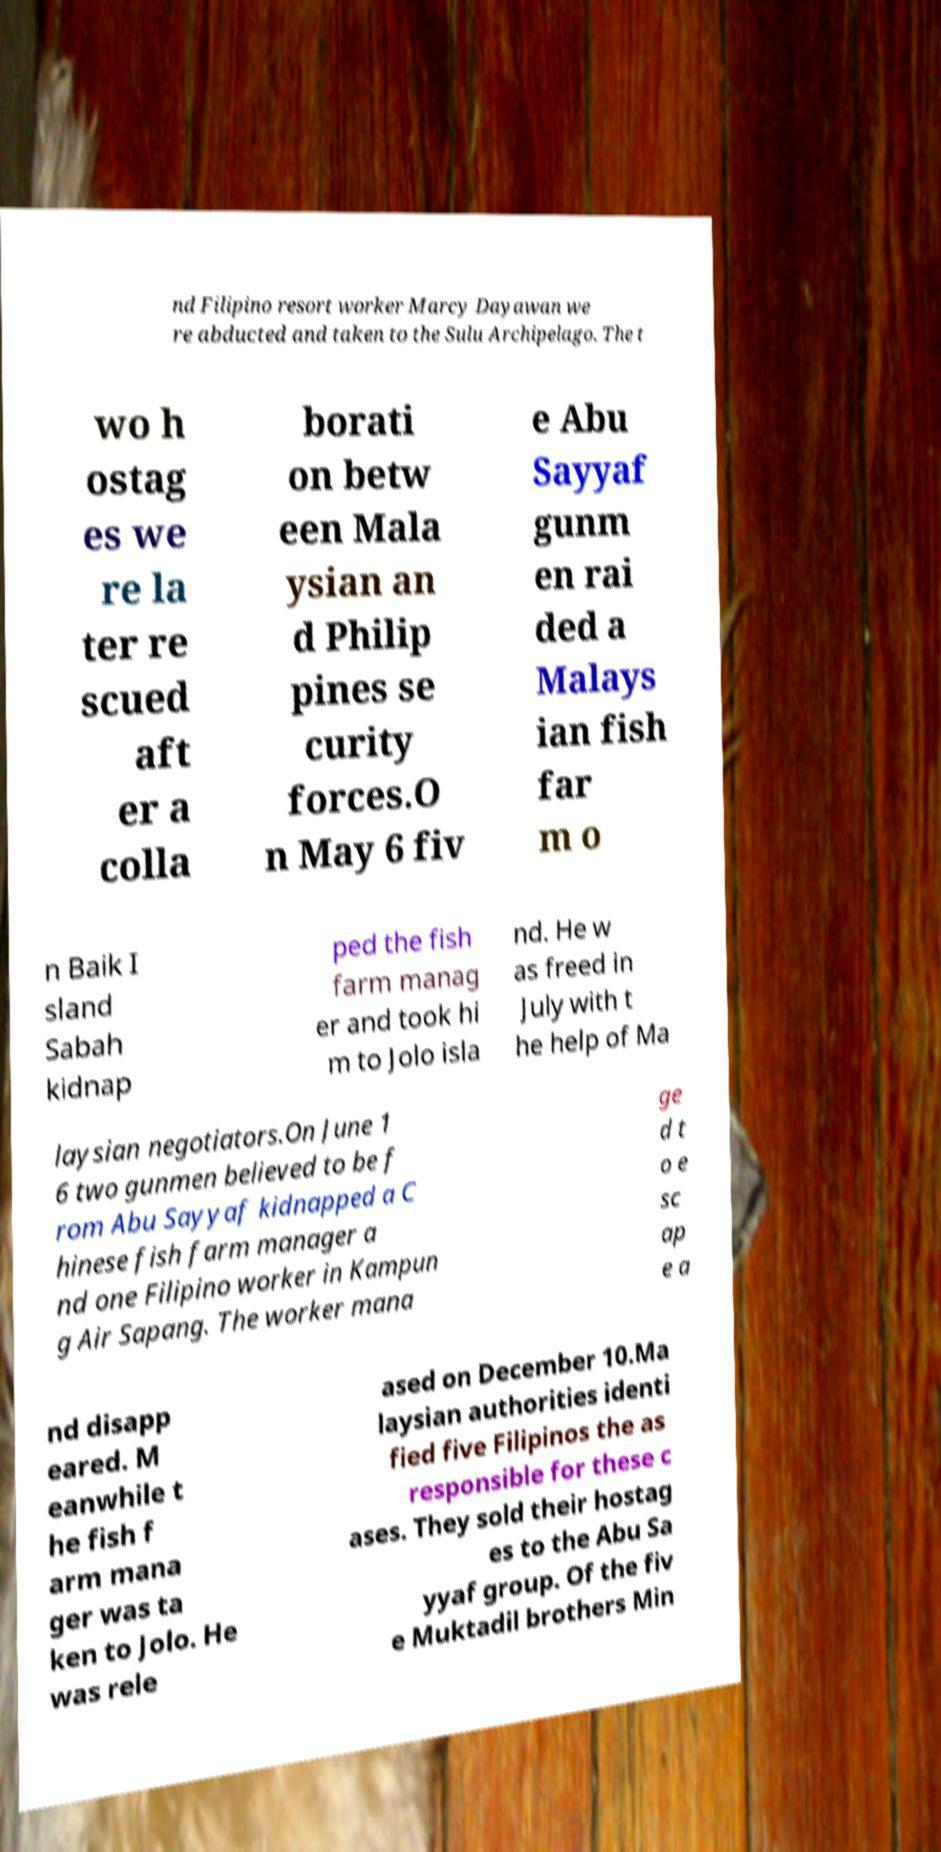For documentation purposes, I need the text within this image transcribed. Could you provide that? nd Filipino resort worker Marcy Dayawan we re abducted and taken to the Sulu Archipelago. The t wo h ostag es we re la ter re scued aft er a colla borati on betw een Mala ysian an d Philip pines se curity forces.O n May 6 fiv e Abu Sayyaf gunm en rai ded a Malays ian fish far m o n Baik I sland Sabah kidnap ped the fish farm manag er and took hi m to Jolo isla nd. He w as freed in July with t he help of Ma laysian negotiators.On June 1 6 two gunmen believed to be f rom Abu Sayyaf kidnapped a C hinese fish farm manager a nd one Filipino worker in Kampun g Air Sapang. The worker mana ge d t o e sc ap e a nd disapp eared. M eanwhile t he fish f arm mana ger was ta ken to Jolo. He was rele ased on December 10.Ma laysian authorities identi fied five Filipinos the as responsible for these c ases. They sold their hostag es to the Abu Sa yyaf group. Of the fiv e Muktadil brothers Min 